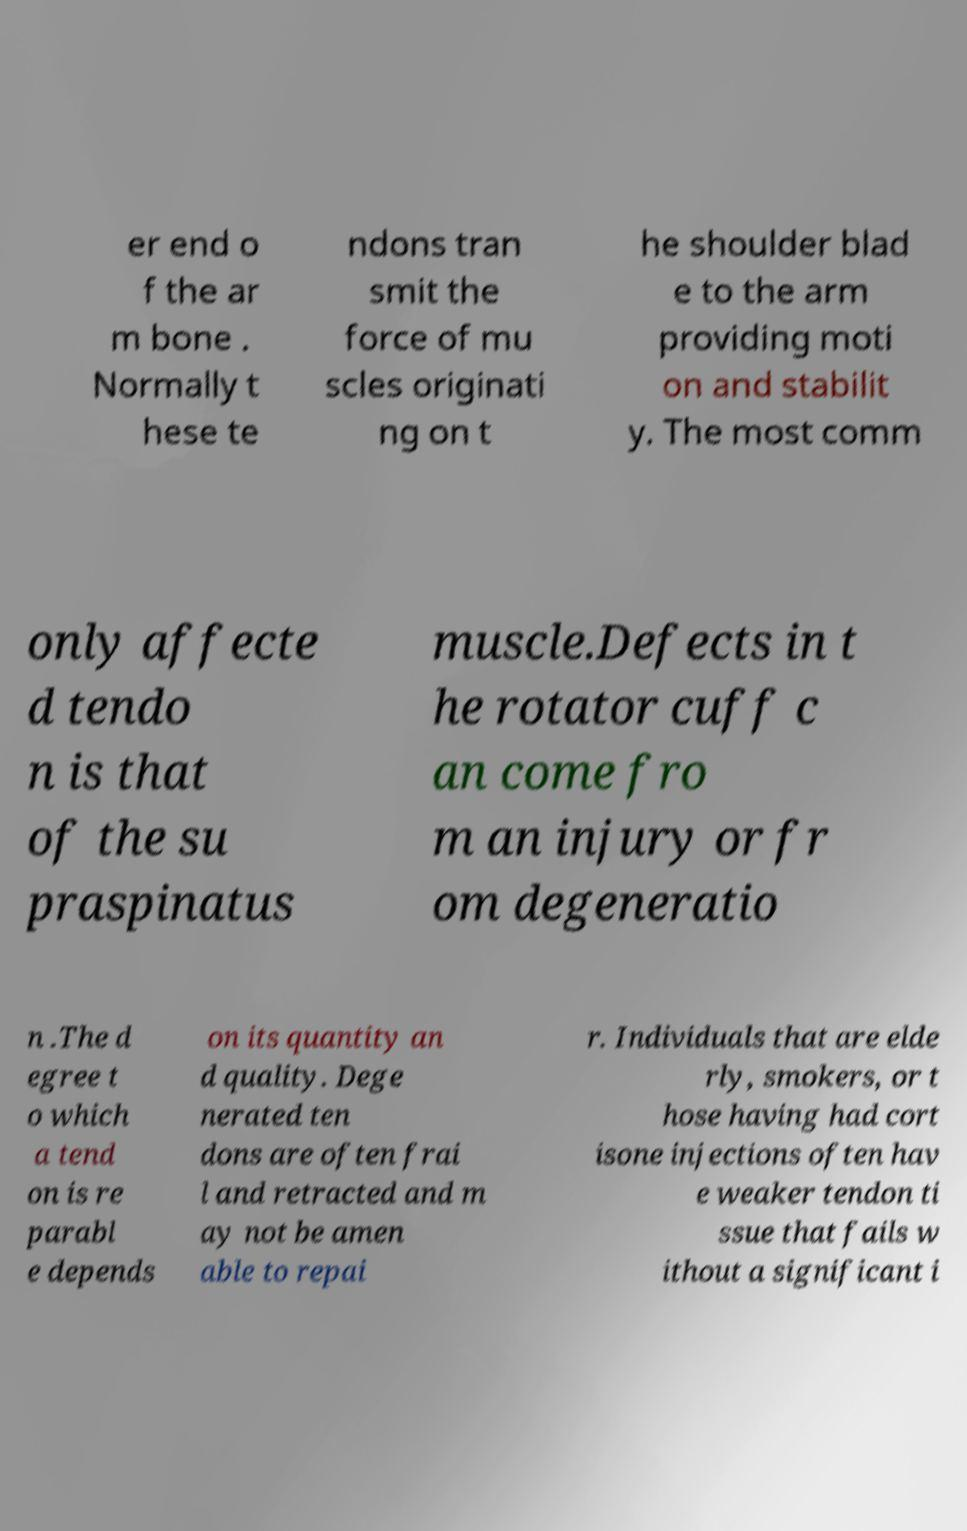I need the written content from this picture converted into text. Can you do that? er end o f the ar m bone . Normally t hese te ndons tran smit the force of mu scles originati ng on t he shoulder blad e to the arm providing moti on and stabilit y. The most comm only affecte d tendo n is that of the su praspinatus muscle.Defects in t he rotator cuff c an come fro m an injury or fr om degeneratio n .The d egree t o which a tend on is re parabl e depends on its quantity an d quality. Dege nerated ten dons are often frai l and retracted and m ay not be amen able to repai r. Individuals that are elde rly, smokers, or t hose having had cort isone injections often hav e weaker tendon ti ssue that fails w ithout a significant i 